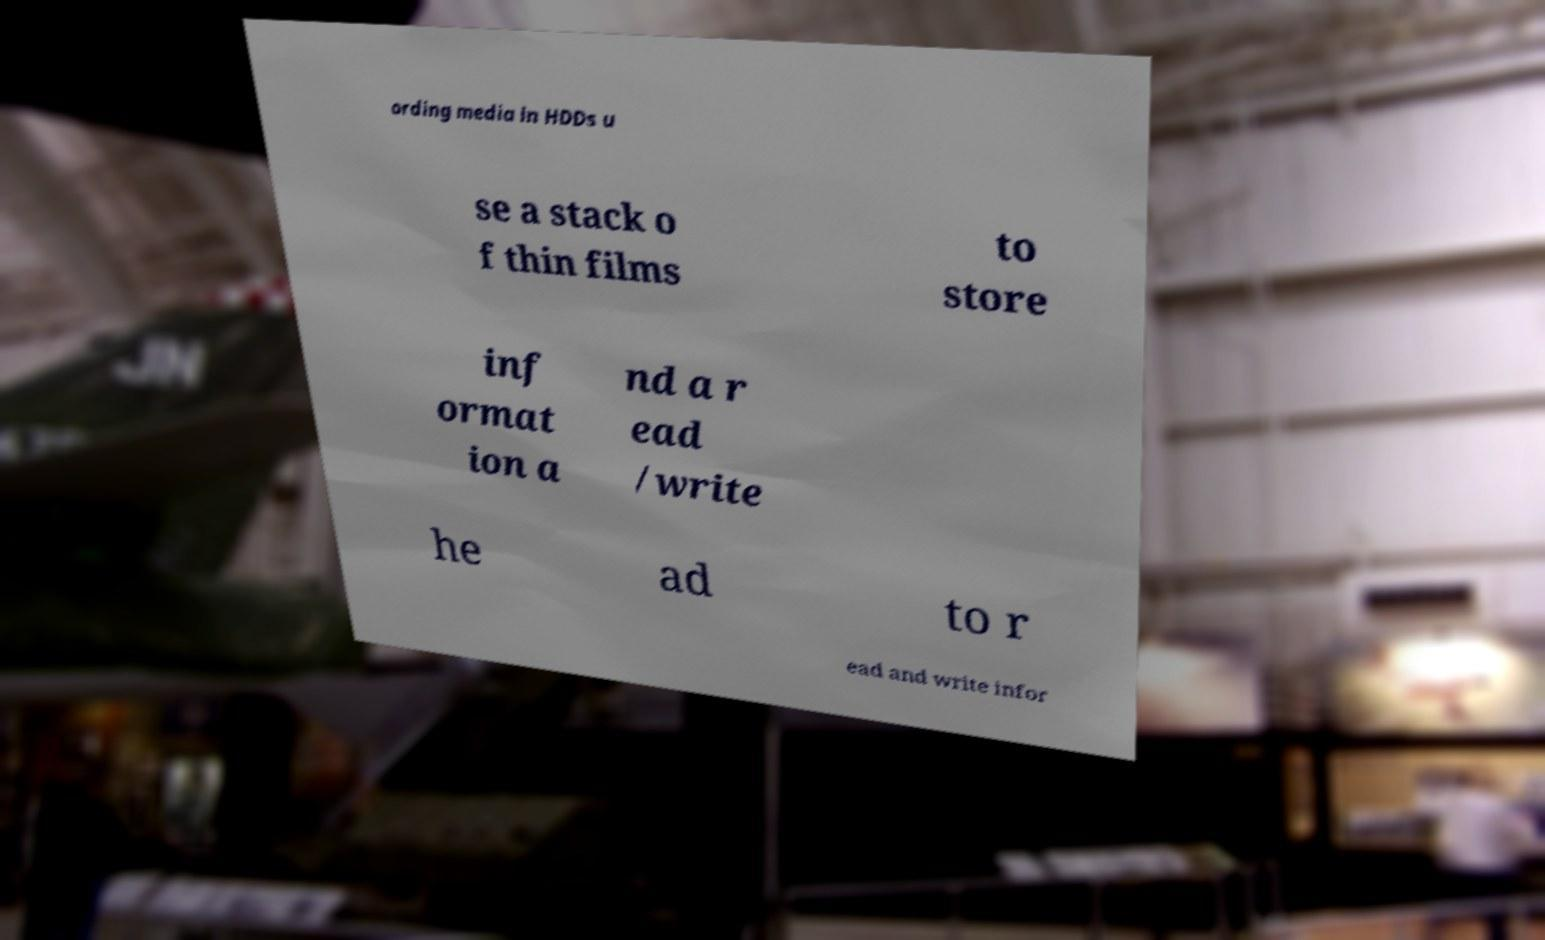What messages or text are displayed in this image? I need them in a readable, typed format. ording media in HDDs u se a stack o f thin films to store inf ormat ion a nd a r ead /write he ad to r ead and write infor 